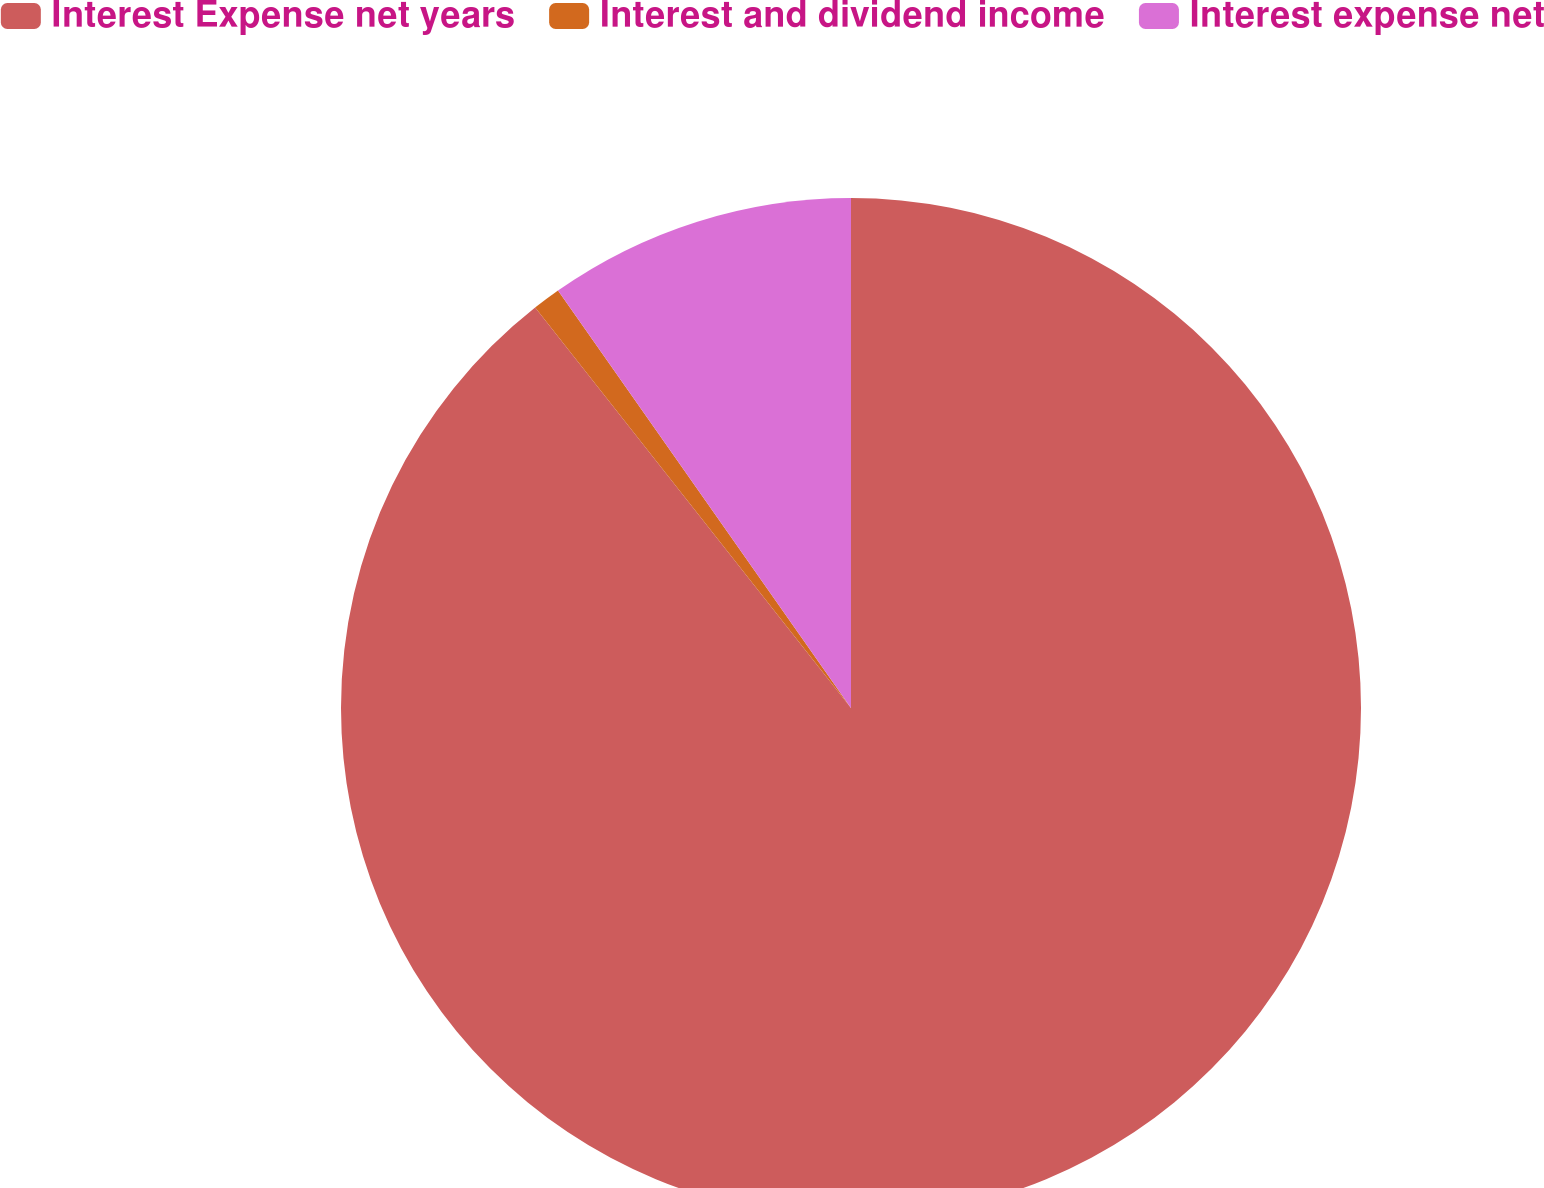Convert chart to OTSL. <chart><loc_0><loc_0><loc_500><loc_500><pie_chart><fcel>Interest Expense net years<fcel>Interest and dividend income<fcel>Interest expense net<nl><fcel>89.37%<fcel>0.89%<fcel>9.74%<nl></chart> 